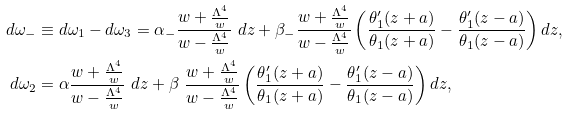<formula> <loc_0><loc_0><loc_500><loc_500>d \omega _ { - } & \equiv d \omega _ { 1 } - d \omega _ { 3 } = \alpha _ { - } \frac { w + \frac { \Lambda ^ { 4 } } { w } } { w - \frac { \Lambda ^ { 4 } } { w } } \ d z + \beta _ { - } \frac { w + \frac { \Lambda ^ { 4 } } { w } } { w - \frac { \Lambda ^ { 4 } } { w } } \left ( \frac { \theta _ { 1 } ^ { \prime } ( z + a ) } { \theta _ { 1 } ( z + a ) } - \frac { \theta _ { 1 } ^ { \prime } ( z - a ) } { \theta _ { 1 } ( z - a ) } \right ) d z , \\ d \omega _ { 2 } & = \alpha \frac { w + \frac { \Lambda ^ { 4 } } { w } } { w - \frac { \Lambda ^ { 4 } } { w } } \ d z + \beta \ \frac { w + \frac { \Lambda ^ { 4 } } { w } } { w - \frac { \Lambda ^ { 4 } } { w } } \left ( \frac { \theta _ { 1 } ^ { \prime } ( z + a ) } { \theta _ { 1 } ( z + a ) } - \frac { \theta _ { 1 } ^ { \prime } ( z - a ) } { \theta _ { 1 } ( z - a ) } \right ) d z ,</formula> 